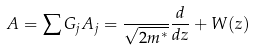Convert formula to latex. <formula><loc_0><loc_0><loc_500><loc_500>A = \sum G _ { j } A _ { j } = \frac { } { \sqrt { 2 m ^ { * } } } \frac { d } { d z } + W ( z )</formula> 